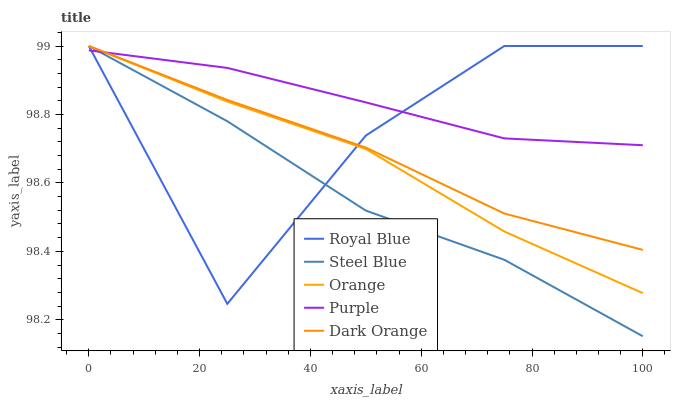Does Steel Blue have the minimum area under the curve?
Answer yes or no. Yes. Does Purple have the maximum area under the curve?
Answer yes or no. Yes. Does Royal Blue have the minimum area under the curve?
Answer yes or no. No. Does Royal Blue have the maximum area under the curve?
Answer yes or no. No. Is Purple the smoothest?
Answer yes or no. Yes. Is Royal Blue the roughest?
Answer yes or no. Yes. Is Steel Blue the smoothest?
Answer yes or no. No. Is Steel Blue the roughest?
Answer yes or no. No. Does Royal Blue have the lowest value?
Answer yes or no. No. Does Dark Orange have the highest value?
Answer yes or no. Yes. Does Purple have the highest value?
Answer yes or no. No. Does Purple intersect Dark Orange?
Answer yes or no. Yes. Is Purple less than Dark Orange?
Answer yes or no. No. Is Purple greater than Dark Orange?
Answer yes or no. No. 